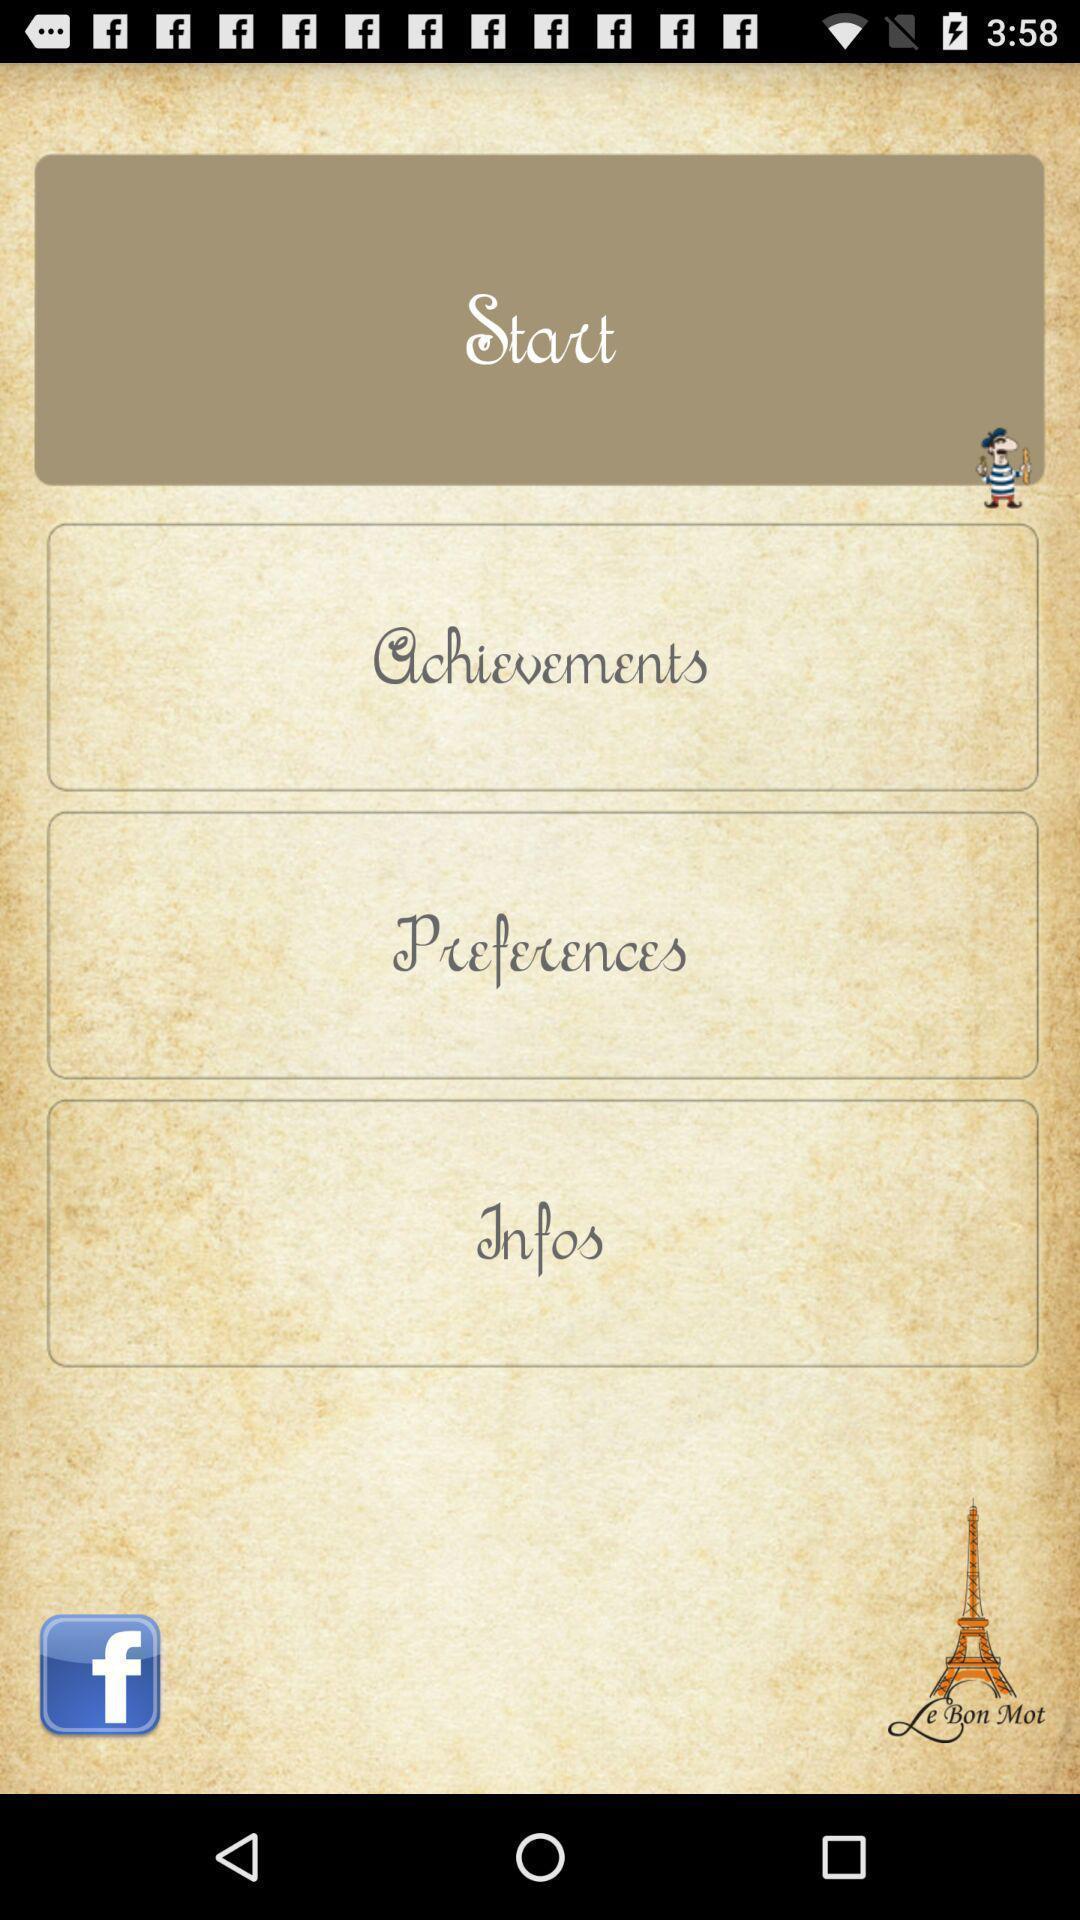Describe the visual elements of this screenshot. Window displaying a learning app. 